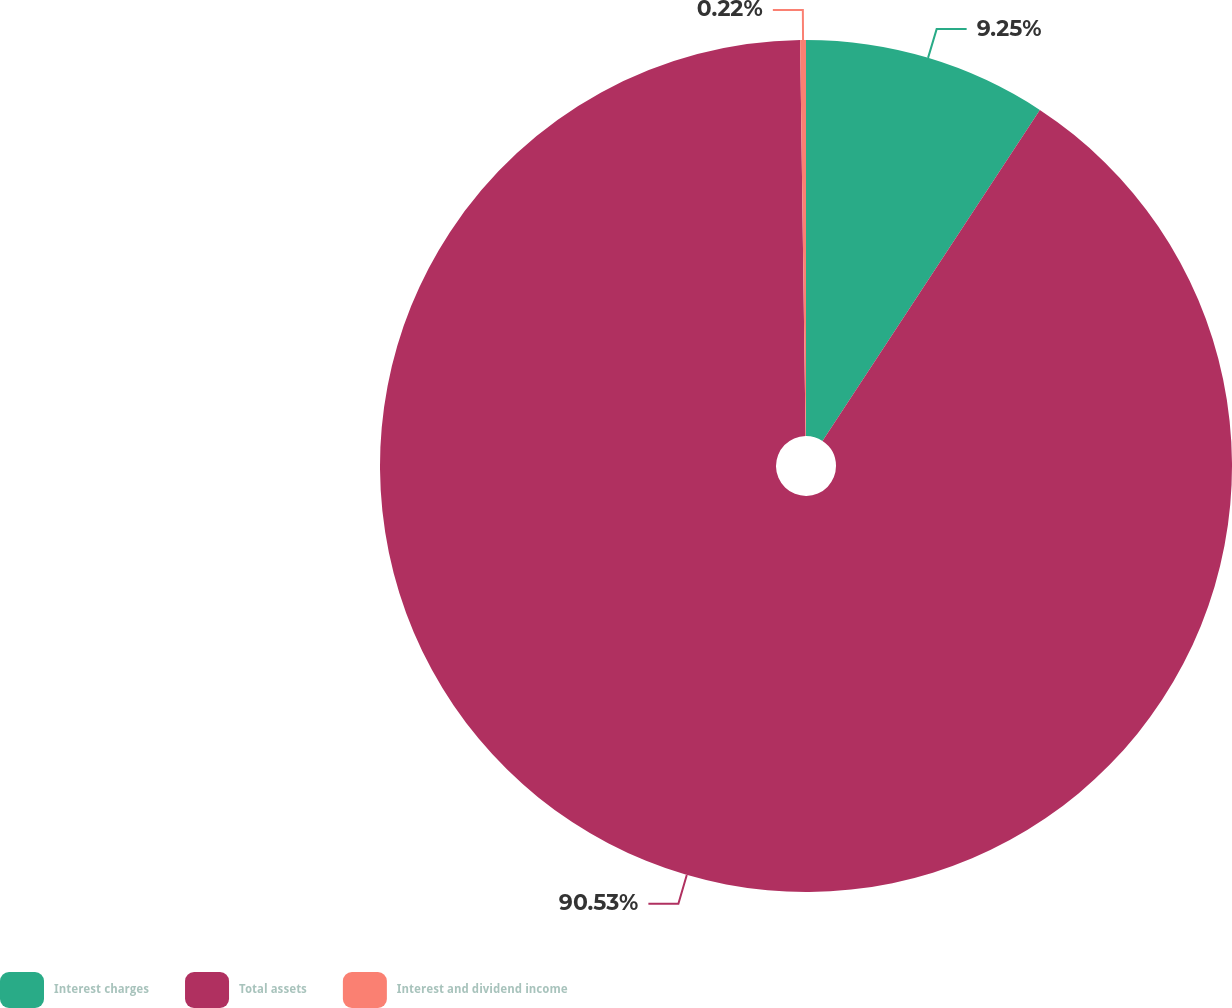Convert chart. <chart><loc_0><loc_0><loc_500><loc_500><pie_chart><fcel>Interest charges<fcel>Total assets<fcel>Interest and dividend income<nl><fcel>9.25%<fcel>90.54%<fcel>0.22%<nl></chart> 